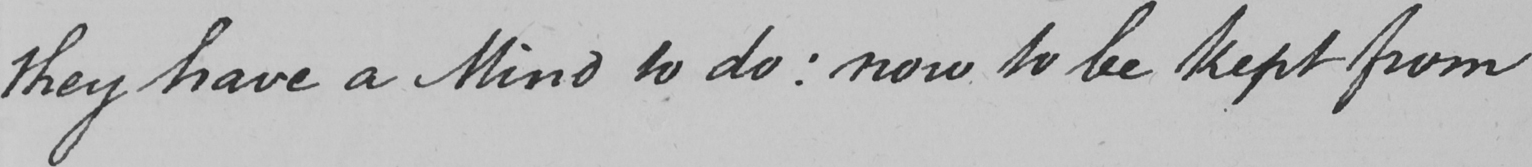What does this handwritten line say? they have a Mind to do :  now to be kept from 